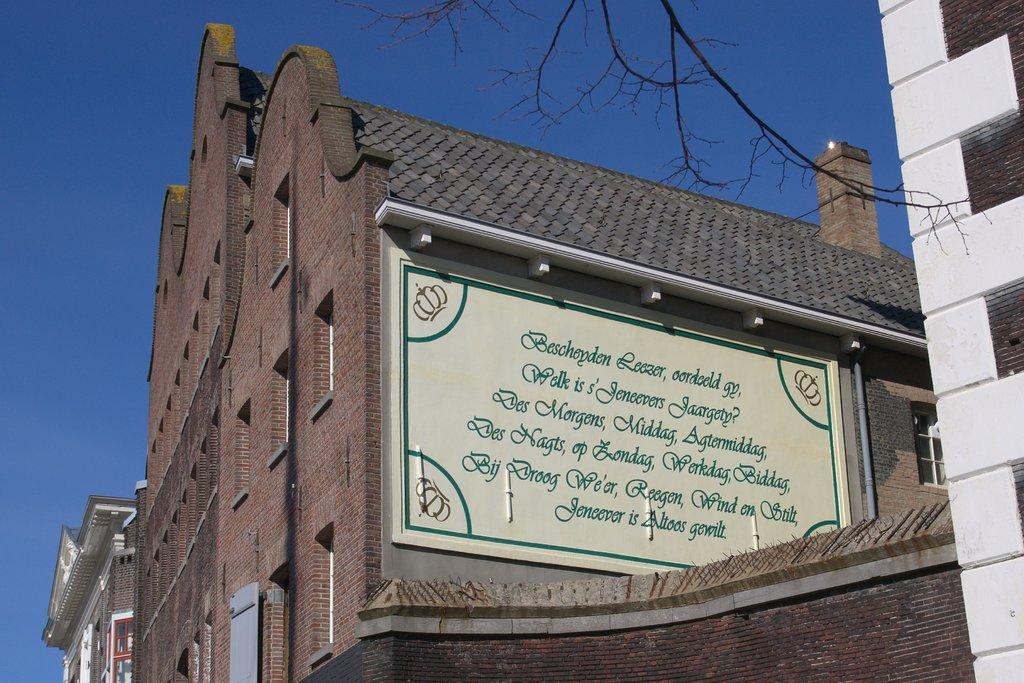What type of structures can be seen in the image? There are buildings in the image. Can you describe any specific features of the buildings? There is an information board on one side of the building and a chimney in the image. What else can be seen in the image besides the buildings? There are trees and pipelines visible in the image. What is visible in the background of the image? The sky is visible in the image. What type of stomach pain is the chimney experiencing in the image? Chimneys do not experience stomach pain, as they are inanimate objects. There is no indication of any living being experiencing pain in the image. 